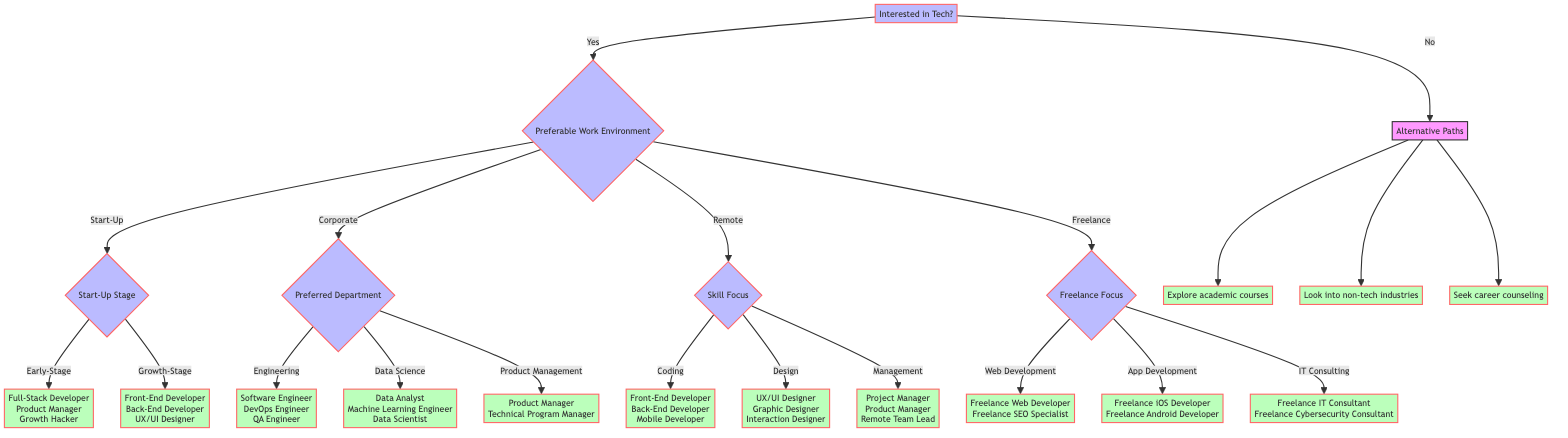What's the first question in the decision tree? The first question in the decision tree is "Interested in Tech?" which is the starting point for all subsequent decisions and options.
Answer: Interested in Tech? How many options are there under Preferable Work Environment? There are four options listed under Preferable Work Environment: Start-Up, Corporate, Remote, and Freelance.
Answer: 4 What roles can be found in the Early-Stage of a Start-Up? In the Early-Stage of a Start-Up, the roles mentioned are Full-Stack Developer, Product Manager, and Growth Hacker.
Answer: Full-Stack Developer, Product Manager, Growth Hacker Which departments are available under Corporate? The available departments under Corporate are Engineering, Data Science, and Product Management.
Answer: Engineering, Data Science, Product Management What are the two main focuses of Freelance work? The two main focuses of Freelance work in the diagram are Web Development and App Development, along with IT Consulting.
Answer: Web Development, App Development, IT Consulting If someone is interested in remote work and focuses on management skills, what roles would they consider? If someone focuses on management skills in remote work, they would consider the roles of Project Manager, Product Manager, and Remote Team Lead.
Answer: Project Manager, Product Manager, Remote Team Lead How many roles are associated with Data Science under Corporate? There are three roles associated with Data Science under Corporate: Data Analyst, Machine Learning Engineer, and Data Scientist.
Answer: 3 What should someone do if they answer 'No' to being interested in tech? If someone answers 'No' to being interested in tech, they should explore academic courses, look into non-tech industries, or seek career counseling.
Answer: Explore academic courses, Look into non-tech industries, Seek career counseling What happens after selecting Remote work? After selecting Remote work, the next step is to determine Skill Focus, which includes Coding, Design, or Management.
Answer: Skill Focus How many roles are listed for Freelance App Development? For Freelance App Development, there are two roles listed: Freelance iOS Developer and Freelance Android Developer.
Answer: 2 